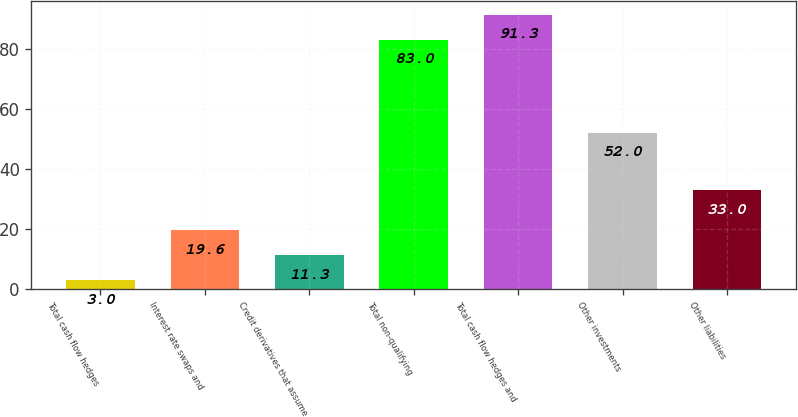<chart> <loc_0><loc_0><loc_500><loc_500><bar_chart><fcel>Total cash flow hedges<fcel>Interest rate swaps and<fcel>Credit derivatives that assume<fcel>Total non-qualifying<fcel>Total cash flow hedges and<fcel>Other investments<fcel>Other liabilities<nl><fcel>3<fcel>19.6<fcel>11.3<fcel>83<fcel>91.3<fcel>52<fcel>33<nl></chart> 